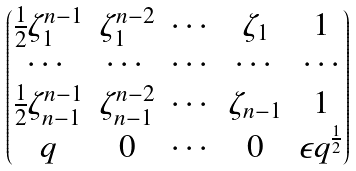<formula> <loc_0><loc_0><loc_500><loc_500>\begin{pmatrix} \frac { 1 } { 2 } \zeta _ { 1 } ^ { n - 1 } & \zeta _ { 1 } ^ { n - 2 } & \cdots & \zeta _ { 1 } & 1 \\ \cdots & \cdots & \cdots & \cdots & \cdots \\ \frac { 1 } { 2 } \zeta _ { n - 1 } ^ { n - 1 } & \zeta _ { n - 1 } ^ { n - 2 } & \cdots & \zeta _ { n - 1 } & 1 \\ q & 0 & \cdots & 0 & \epsilon q ^ { \frac { 1 } { 2 } } \end{pmatrix}</formula> 